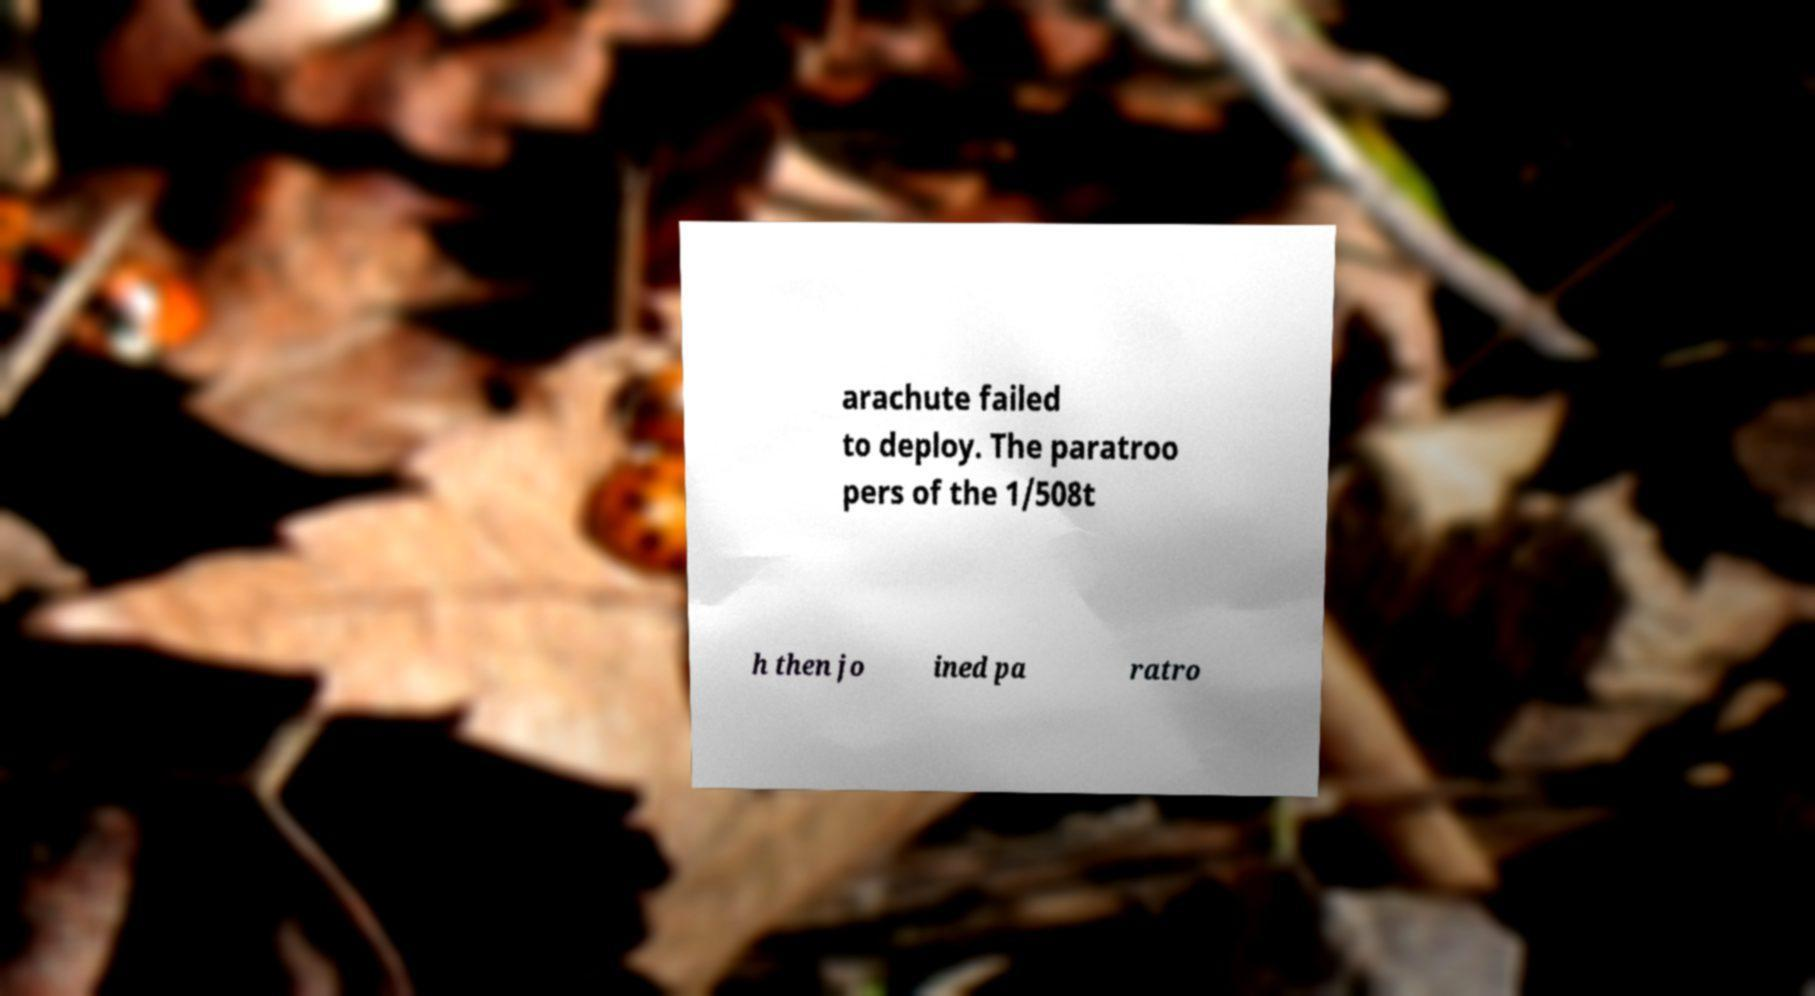Please read and relay the text visible in this image. What does it say? arachute failed to deploy. The paratroo pers of the 1/508t h then jo ined pa ratro 